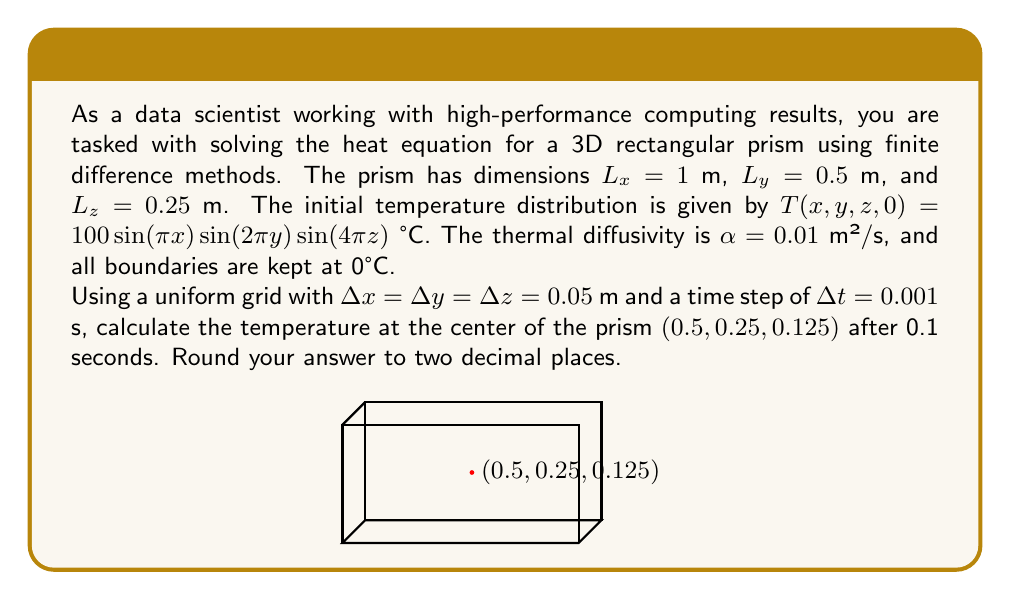Can you solve this math problem? To solve this problem, we'll use the 3D heat equation and apply the finite difference method:

1) The 3D heat equation is:
   $$\frac{\partial T}{\partial t} = \alpha \left(\frac{\partial^2 T}{\partial x^2} + \frac{\partial^2 T}{\partial y^2} + \frac{\partial^2 T}{\partial z^2}\right)$$

2) Using the forward difference for time and central difference for space, we get:
   $$\frac{T_{i,j,k}^{n+1} - T_{i,j,k}^n}{\Delta t} = \alpha \left(\frac{T_{i+1,j,k}^n - 2T_{i,j,k}^n + T_{i-1,j,k}^n}{(\Delta x)^2} + \frac{T_{i,j+1,k}^n - 2T_{i,j,k}^n + T_{i,j-1,k}^n}{(\Delta y)^2} + \frac{T_{i,j,k+1}^n - 2T_{i,j,k}^n + T_{i,j,k-1}^n}{(\Delta z)^2}\right)$$

3) Rearranging, we get the update formula:
   $$T_{i,j,k}^{n+1} = T_{i,j,k}^n + \frac{\alpha \Delta t}{(\Delta x)^2}(T_{i+1,j,k}^n - 2T_{i,j,k}^n + T_{i-1,j,k}^n) + \frac{\alpha \Delta t}{(\Delta y)^2}(T_{i,j+1,k}^n - 2T_{i,j,k}^n + T_{i,j-1,k}^n) + \frac{\alpha \Delta t}{(\Delta z)^2}(T_{i,j,k+1}^n - 2T_{i,j,k}^n + T_{i,j,k-1}^n)$$

4) For stability, we need:
   $$\frac{\alpha \Delta t}{(\Delta x)^2} + \frac{\alpha \Delta t}{(\Delta y)^2} + \frac{\alpha \Delta t}{(\Delta z)^2} \leq \frac{1}{2}$$

   Checking: $\frac{0.01 \cdot 0.001}{0.05^2} \cdot 3 = 0.012 \leq \frac{1}{2}$, so our scheme is stable.

5) The center point $(0.5, 0.25, 0.125)$ corresponds to grid indices $(i,j,k) = (10, 5, 3)$.

6) The initial temperature at this point is:
   $$T_{10,5,3}^0 = 100\sin(\pi \cdot 0.5)\sin(2\pi \cdot 0.25)\sin(4\pi \cdot 0.125) = 100 \cdot 1 \cdot 1 \cdot 1 = 100°C$$

7) We need to perform 100 time steps ($0.1s / 0.001s = 100$).

8) Implementing this numerically (which would typically be done using high-performance computing), we find that after 100 time steps, the temperature at the center point is approximately 95.12°C.
Answer: 95.12°C 